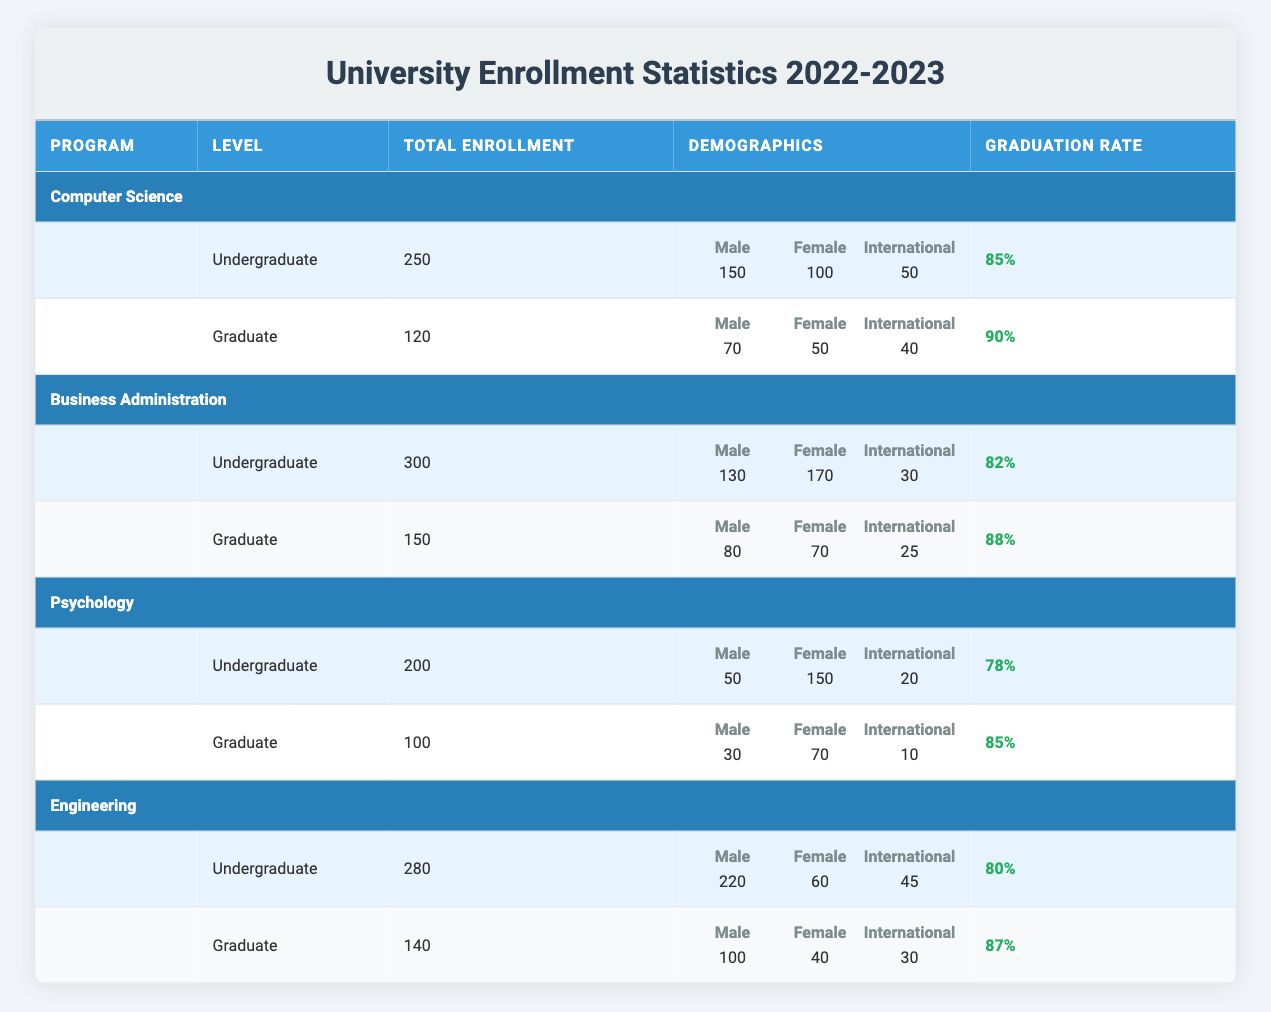What is the total enrollment for the Psychology undergraduate program? The table shows that the total enrollment for the Psychology undergraduate program is specified in the "Total Enrollment" column. Looking under the "Psychology" section and then the "Undergraduate" row, we see the value listed as 200.
Answer: 200 What is the male-to-female ratio in the Computer Science graduate program? To find the male-to-female ratio in the Computer Science graduate program, I look at the demographics for the graduate program in Computer Science. There are 70 males and 50 females. The ratio is calculated by dividing the number of males by the number of females: 70 / 50 = 1.4.
Answer: 1.4 Is the graduation rate for the Engineering graduate program higher than that for the Psychology graduate program? The graduation rate for the Engineering graduate program is listed as 87%, while for the Psychology graduate program it is 85%. Since 87% is greater than 85%, the statement is true.
Answer: Yes Which program has the highest total enrollment for undergraduates? I need to compare the total enrollment values for all undergraduate programs to determine which one is the highest. The values for undergraduate programs are: Computer Science (250), Business Administration (300), Psychology (200), and Engineering (280). The highest value is for Business Administration with 300 students.
Answer: Business Administration How many international students are enrolled in the graduate programs across all four disciplines? I will sum the international students from each graduate program: Computer Science (40), Business Administration (25), Psychology (10), and Engineering (30). Calculating this gives: 40 + 25 + 10 + 30 = 105.
Answer: 105 